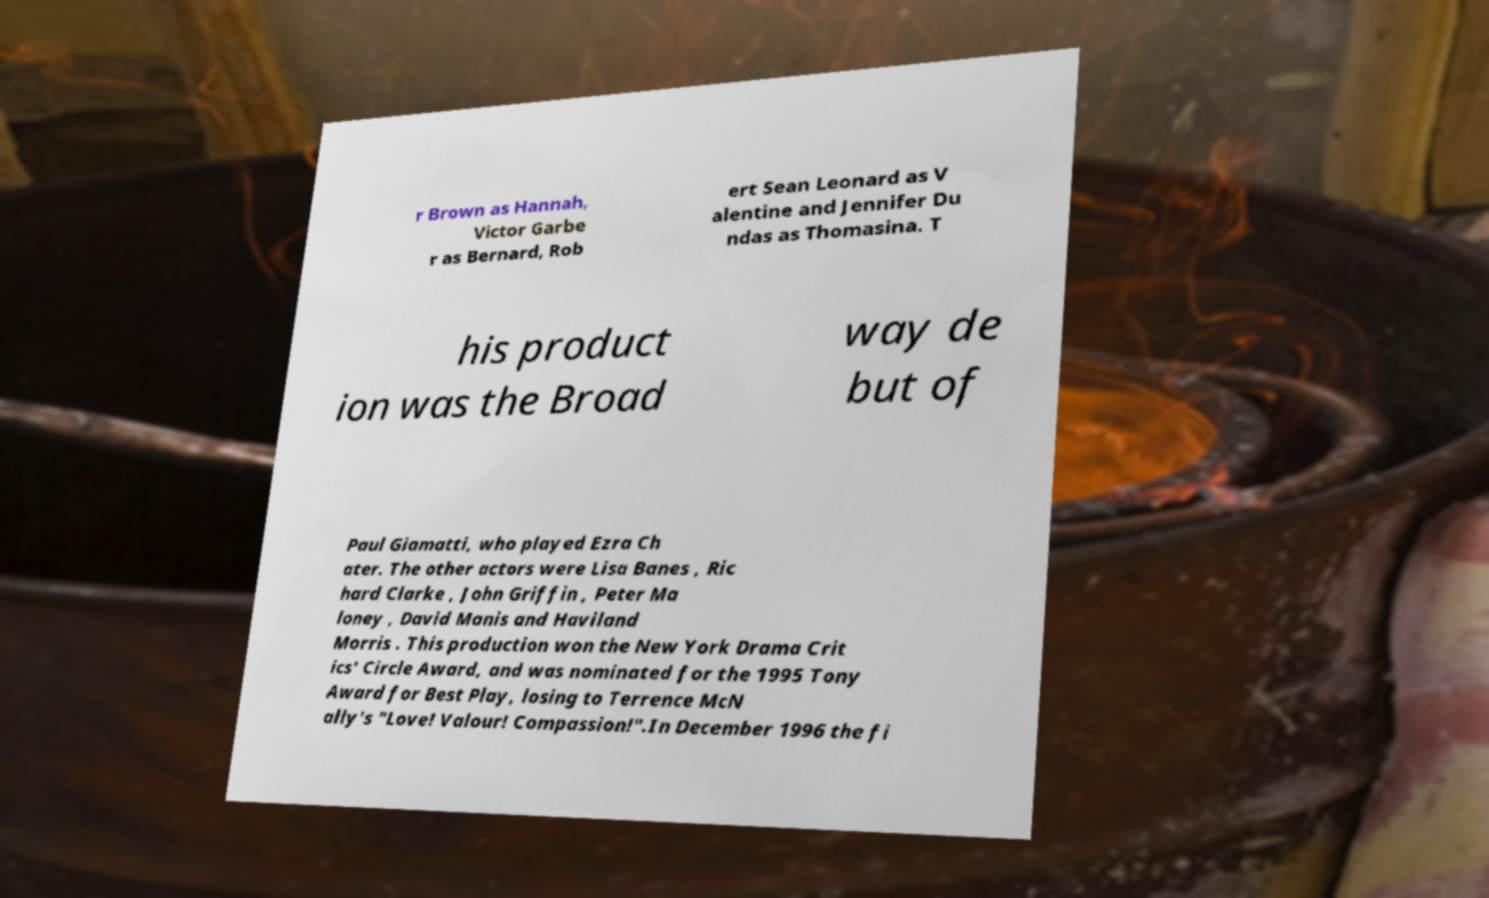There's text embedded in this image that I need extracted. Can you transcribe it verbatim? r Brown as Hannah, Victor Garbe r as Bernard, Rob ert Sean Leonard as V alentine and Jennifer Du ndas as Thomasina. T his product ion was the Broad way de but of Paul Giamatti, who played Ezra Ch ater. The other actors were Lisa Banes , Ric hard Clarke , John Griffin , Peter Ma loney , David Manis and Haviland Morris . This production won the New York Drama Crit ics' Circle Award, and was nominated for the 1995 Tony Award for Best Play, losing to Terrence McN ally's "Love! Valour! Compassion!".In December 1996 the fi 